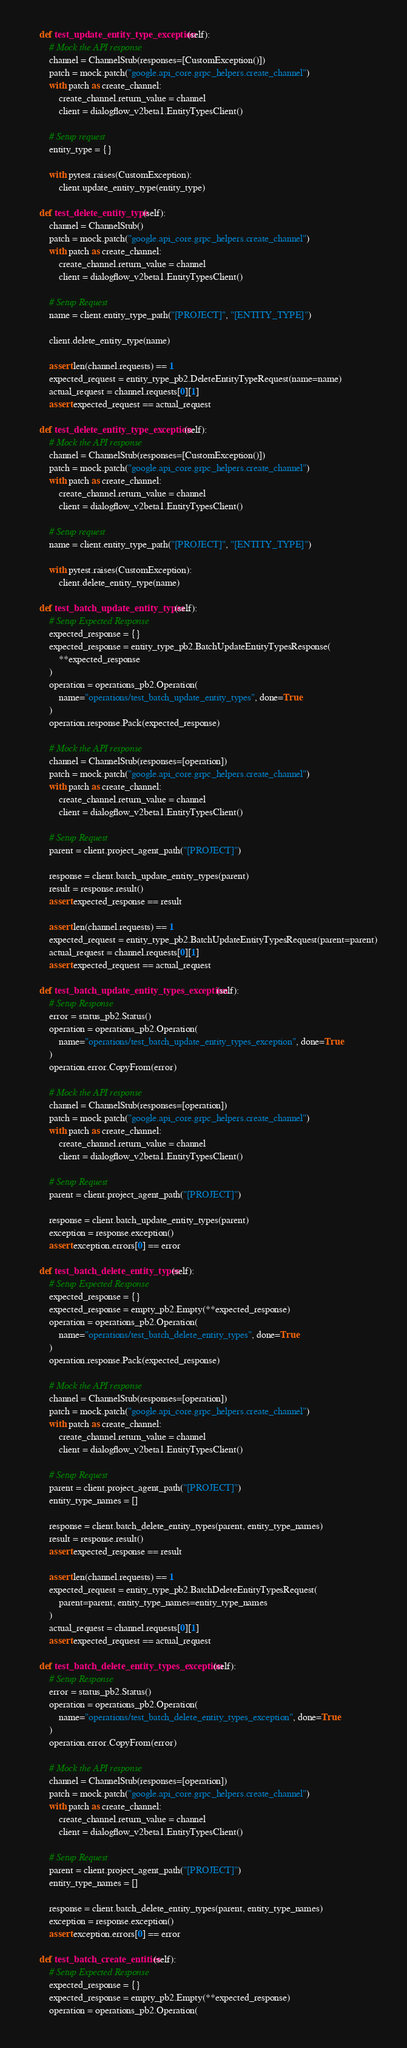Convert code to text. <code><loc_0><loc_0><loc_500><loc_500><_Python_>    def test_update_entity_type_exception(self):
        # Mock the API response
        channel = ChannelStub(responses=[CustomException()])
        patch = mock.patch("google.api_core.grpc_helpers.create_channel")
        with patch as create_channel:
            create_channel.return_value = channel
            client = dialogflow_v2beta1.EntityTypesClient()

        # Setup request
        entity_type = {}

        with pytest.raises(CustomException):
            client.update_entity_type(entity_type)

    def test_delete_entity_type(self):
        channel = ChannelStub()
        patch = mock.patch("google.api_core.grpc_helpers.create_channel")
        with patch as create_channel:
            create_channel.return_value = channel
            client = dialogflow_v2beta1.EntityTypesClient()

        # Setup Request
        name = client.entity_type_path("[PROJECT]", "[ENTITY_TYPE]")

        client.delete_entity_type(name)

        assert len(channel.requests) == 1
        expected_request = entity_type_pb2.DeleteEntityTypeRequest(name=name)
        actual_request = channel.requests[0][1]
        assert expected_request == actual_request

    def test_delete_entity_type_exception(self):
        # Mock the API response
        channel = ChannelStub(responses=[CustomException()])
        patch = mock.patch("google.api_core.grpc_helpers.create_channel")
        with patch as create_channel:
            create_channel.return_value = channel
            client = dialogflow_v2beta1.EntityTypesClient()

        # Setup request
        name = client.entity_type_path("[PROJECT]", "[ENTITY_TYPE]")

        with pytest.raises(CustomException):
            client.delete_entity_type(name)

    def test_batch_update_entity_types(self):
        # Setup Expected Response
        expected_response = {}
        expected_response = entity_type_pb2.BatchUpdateEntityTypesResponse(
            **expected_response
        )
        operation = operations_pb2.Operation(
            name="operations/test_batch_update_entity_types", done=True
        )
        operation.response.Pack(expected_response)

        # Mock the API response
        channel = ChannelStub(responses=[operation])
        patch = mock.patch("google.api_core.grpc_helpers.create_channel")
        with patch as create_channel:
            create_channel.return_value = channel
            client = dialogflow_v2beta1.EntityTypesClient()

        # Setup Request
        parent = client.project_agent_path("[PROJECT]")

        response = client.batch_update_entity_types(parent)
        result = response.result()
        assert expected_response == result

        assert len(channel.requests) == 1
        expected_request = entity_type_pb2.BatchUpdateEntityTypesRequest(parent=parent)
        actual_request = channel.requests[0][1]
        assert expected_request == actual_request

    def test_batch_update_entity_types_exception(self):
        # Setup Response
        error = status_pb2.Status()
        operation = operations_pb2.Operation(
            name="operations/test_batch_update_entity_types_exception", done=True
        )
        operation.error.CopyFrom(error)

        # Mock the API response
        channel = ChannelStub(responses=[operation])
        patch = mock.patch("google.api_core.grpc_helpers.create_channel")
        with patch as create_channel:
            create_channel.return_value = channel
            client = dialogflow_v2beta1.EntityTypesClient()

        # Setup Request
        parent = client.project_agent_path("[PROJECT]")

        response = client.batch_update_entity_types(parent)
        exception = response.exception()
        assert exception.errors[0] == error

    def test_batch_delete_entity_types(self):
        # Setup Expected Response
        expected_response = {}
        expected_response = empty_pb2.Empty(**expected_response)
        operation = operations_pb2.Operation(
            name="operations/test_batch_delete_entity_types", done=True
        )
        operation.response.Pack(expected_response)

        # Mock the API response
        channel = ChannelStub(responses=[operation])
        patch = mock.patch("google.api_core.grpc_helpers.create_channel")
        with patch as create_channel:
            create_channel.return_value = channel
            client = dialogflow_v2beta1.EntityTypesClient()

        # Setup Request
        parent = client.project_agent_path("[PROJECT]")
        entity_type_names = []

        response = client.batch_delete_entity_types(parent, entity_type_names)
        result = response.result()
        assert expected_response == result

        assert len(channel.requests) == 1
        expected_request = entity_type_pb2.BatchDeleteEntityTypesRequest(
            parent=parent, entity_type_names=entity_type_names
        )
        actual_request = channel.requests[0][1]
        assert expected_request == actual_request

    def test_batch_delete_entity_types_exception(self):
        # Setup Response
        error = status_pb2.Status()
        operation = operations_pb2.Operation(
            name="operations/test_batch_delete_entity_types_exception", done=True
        )
        operation.error.CopyFrom(error)

        # Mock the API response
        channel = ChannelStub(responses=[operation])
        patch = mock.patch("google.api_core.grpc_helpers.create_channel")
        with patch as create_channel:
            create_channel.return_value = channel
            client = dialogflow_v2beta1.EntityTypesClient()

        # Setup Request
        parent = client.project_agent_path("[PROJECT]")
        entity_type_names = []

        response = client.batch_delete_entity_types(parent, entity_type_names)
        exception = response.exception()
        assert exception.errors[0] == error

    def test_batch_create_entities(self):
        # Setup Expected Response
        expected_response = {}
        expected_response = empty_pb2.Empty(**expected_response)
        operation = operations_pb2.Operation(</code> 